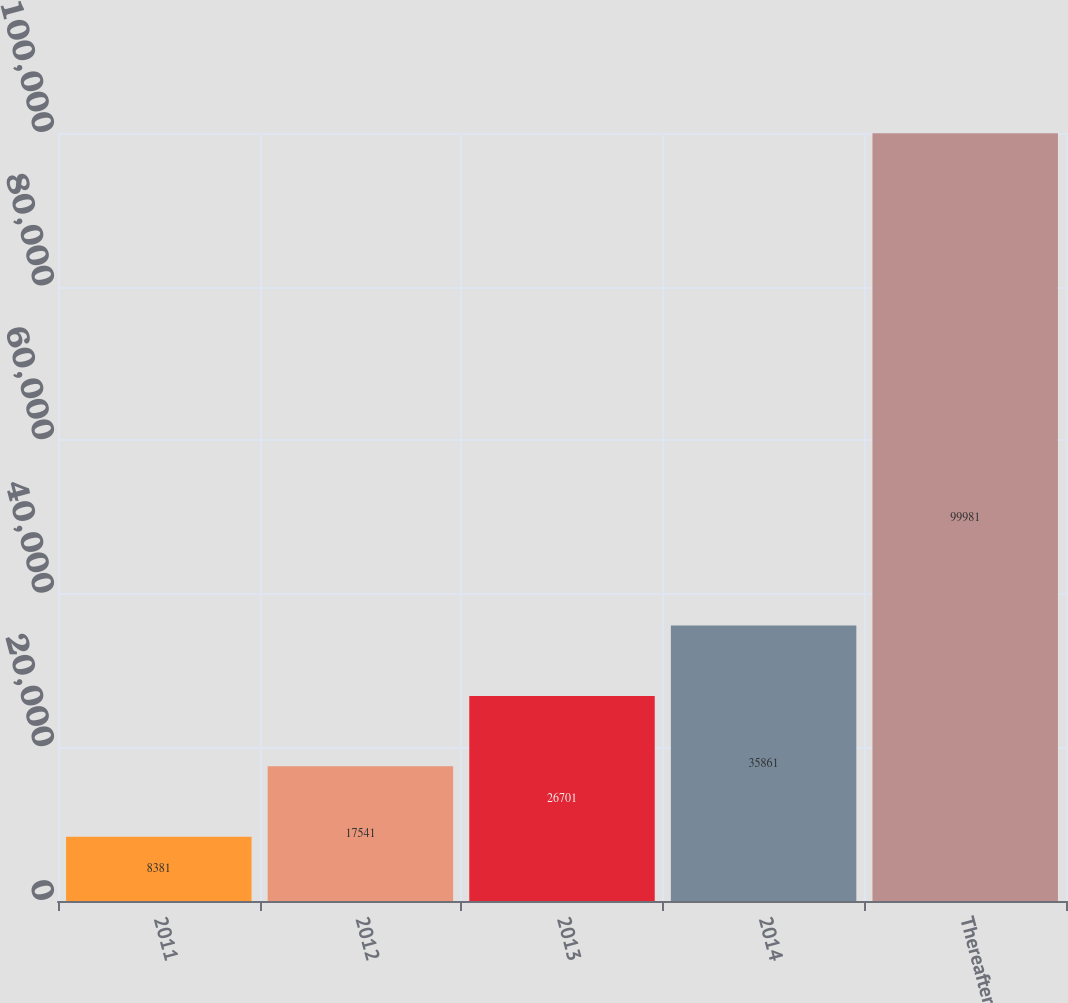Convert chart to OTSL. <chart><loc_0><loc_0><loc_500><loc_500><bar_chart><fcel>2011<fcel>2012<fcel>2013<fcel>2014<fcel>Thereafter<nl><fcel>8381<fcel>17541<fcel>26701<fcel>35861<fcel>99981<nl></chart> 